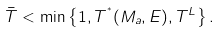Convert formula to latex. <formula><loc_0><loc_0><loc_500><loc_500>\bar { T } < \min \left \{ 1 , T ^ { ^ { * } } ( M _ { a } , E ) , T ^ { L } \right \} .</formula> 